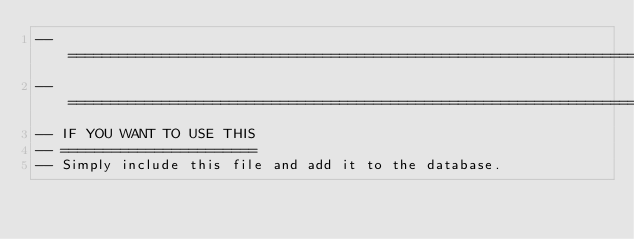<code> <loc_0><loc_0><loc_500><loc_500><_SQL_>--========================================================================================================================================
--========================================================================================================================================
-- IF YOU WANT TO USE THIS
-- =======================
-- Simply include this file and add it to the database.</code> 